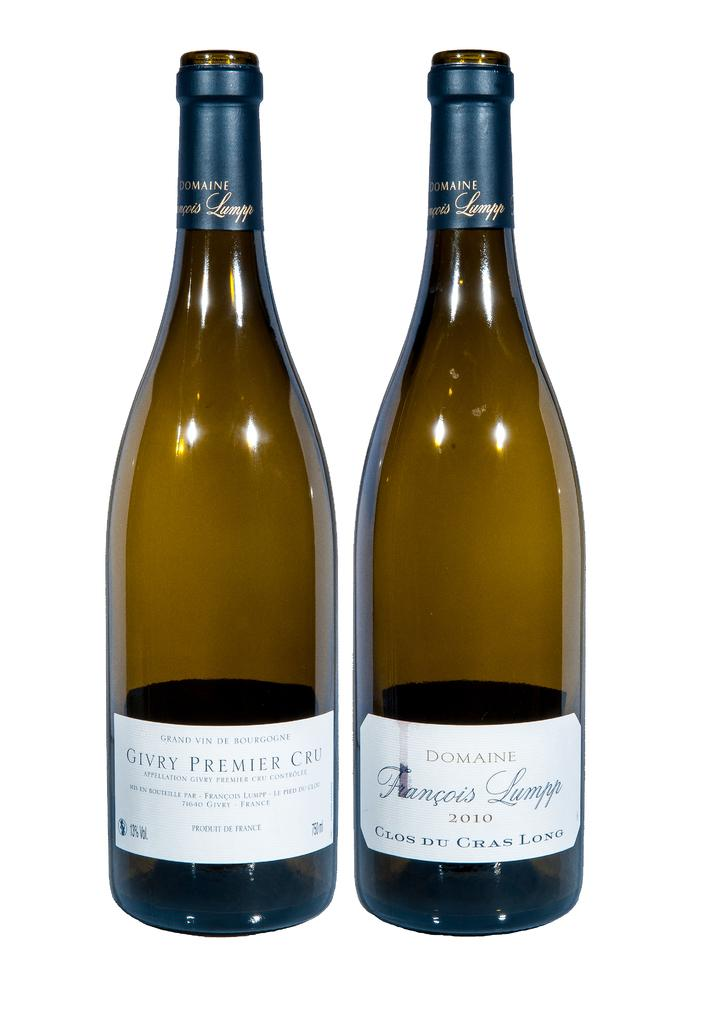<image>
Render a clear and concise summary of the photo. A bottle of Domaine wine sits next to another bottle of the same color. 